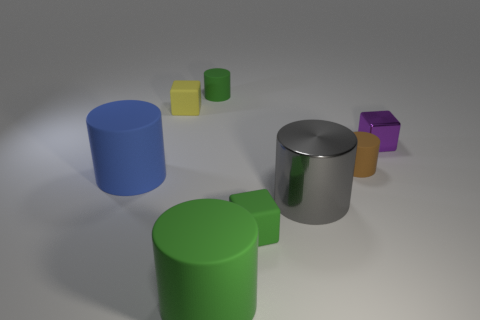Subtract all gray cylinders. How many cylinders are left? 4 Subtract all big gray metal cylinders. How many cylinders are left? 4 Subtract 2 cylinders. How many cylinders are left? 3 Subtract all red cylinders. Subtract all blue balls. How many cylinders are left? 5 Add 2 big green things. How many objects exist? 10 Subtract all blocks. How many objects are left? 5 Subtract all large cyan spheres. Subtract all cylinders. How many objects are left? 3 Add 7 brown cylinders. How many brown cylinders are left? 8 Add 4 small green metal cubes. How many small green metal cubes exist? 4 Subtract 0 green spheres. How many objects are left? 8 